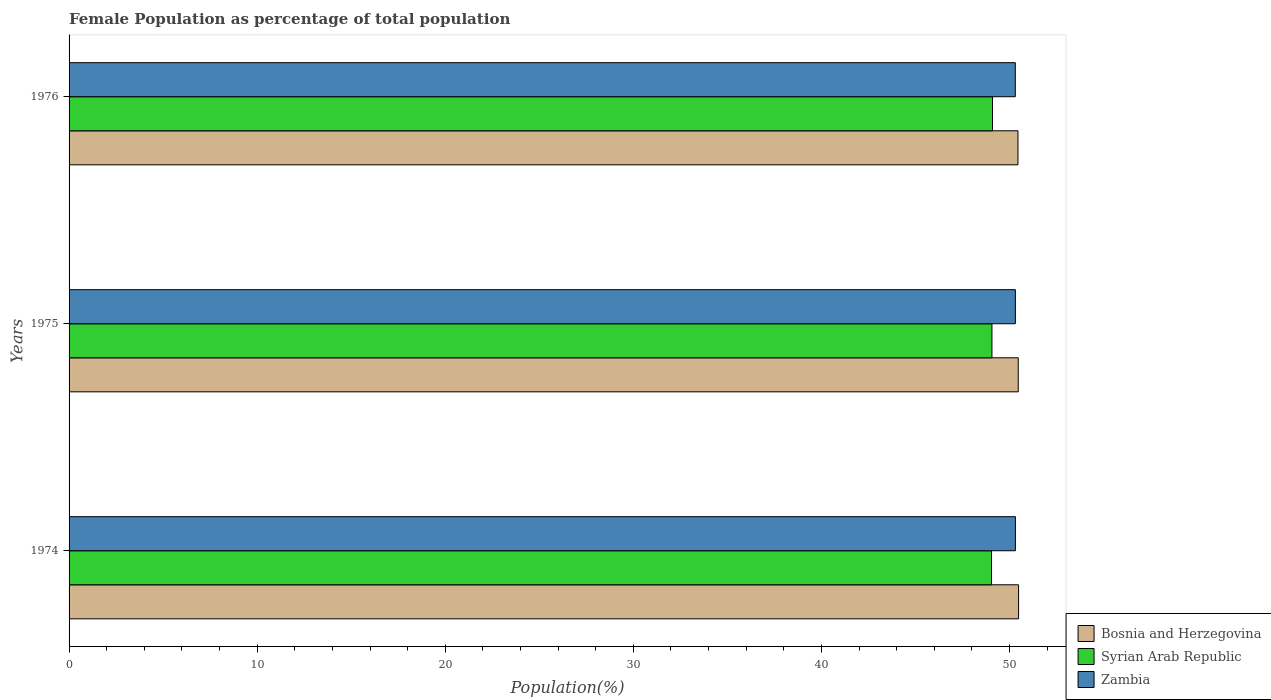How many different coloured bars are there?
Provide a short and direct response. 3. How many groups of bars are there?
Make the answer very short. 3. How many bars are there on the 1st tick from the top?
Your answer should be very brief. 3. How many bars are there on the 3rd tick from the bottom?
Offer a very short reply. 3. What is the label of the 1st group of bars from the top?
Your answer should be very brief. 1976. In how many cases, is the number of bars for a given year not equal to the number of legend labels?
Offer a terse response. 0. What is the female population in in Zambia in 1974?
Offer a very short reply. 50.31. Across all years, what is the maximum female population in in Bosnia and Herzegovina?
Provide a short and direct response. 50.48. Across all years, what is the minimum female population in in Bosnia and Herzegovina?
Your answer should be compact. 50.45. In which year was the female population in in Syrian Arab Republic maximum?
Make the answer very short. 1976. In which year was the female population in in Zambia minimum?
Provide a succinct answer. 1976. What is the total female population in in Zambia in the graph?
Provide a succinct answer. 150.94. What is the difference between the female population in in Syrian Arab Republic in 1975 and that in 1976?
Provide a short and direct response. -0.03. What is the difference between the female population in in Bosnia and Herzegovina in 1976 and the female population in in Syrian Arab Republic in 1974?
Provide a succinct answer. 1.41. What is the average female population in in Syrian Arab Republic per year?
Your answer should be compact. 49.07. In the year 1976, what is the difference between the female population in in Bosnia and Herzegovina and female population in in Zambia?
Your answer should be very brief. 0.14. In how many years, is the female population in in Bosnia and Herzegovina greater than 2 %?
Offer a very short reply. 3. What is the ratio of the female population in in Zambia in 1974 to that in 1975?
Keep it short and to the point. 1. Is the female population in in Syrian Arab Republic in 1975 less than that in 1976?
Offer a very short reply. Yes. Is the difference between the female population in in Bosnia and Herzegovina in 1975 and 1976 greater than the difference between the female population in in Zambia in 1975 and 1976?
Your answer should be very brief. Yes. What is the difference between the highest and the second highest female population in in Zambia?
Give a very brief answer. 0. What is the difference between the highest and the lowest female population in in Bosnia and Herzegovina?
Provide a short and direct response. 0.03. In how many years, is the female population in in Zambia greater than the average female population in in Zambia taken over all years?
Give a very brief answer. 2. What does the 3rd bar from the top in 1975 represents?
Your answer should be compact. Bosnia and Herzegovina. What does the 3rd bar from the bottom in 1974 represents?
Your answer should be very brief. Zambia. How many bars are there?
Ensure brevity in your answer.  9. Are all the bars in the graph horizontal?
Offer a very short reply. Yes. How many years are there in the graph?
Provide a short and direct response. 3. What is the difference between two consecutive major ticks on the X-axis?
Your answer should be very brief. 10. Does the graph contain any zero values?
Your answer should be compact. No. How are the legend labels stacked?
Your answer should be compact. Vertical. What is the title of the graph?
Your response must be concise. Female Population as percentage of total population. Does "Niger" appear as one of the legend labels in the graph?
Give a very brief answer. No. What is the label or title of the X-axis?
Provide a short and direct response. Population(%). What is the label or title of the Y-axis?
Your answer should be very brief. Years. What is the Population(%) of Bosnia and Herzegovina in 1974?
Provide a succinct answer. 50.48. What is the Population(%) in Syrian Arab Republic in 1974?
Provide a succinct answer. 49.04. What is the Population(%) in Zambia in 1974?
Your response must be concise. 50.31. What is the Population(%) of Bosnia and Herzegovina in 1975?
Provide a short and direct response. 50.47. What is the Population(%) in Syrian Arab Republic in 1975?
Your answer should be very brief. 49.07. What is the Population(%) in Zambia in 1975?
Give a very brief answer. 50.31. What is the Population(%) of Bosnia and Herzegovina in 1976?
Your answer should be compact. 50.45. What is the Population(%) in Syrian Arab Republic in 1976?
Make the answer very short. 49.1. What is the Population(%) of Zambia in 1976?
Make the answer very short. 50.31. Across all years, what is the maximum Population(%) in Bosnia and Herzegovina?
Offer a terse response. 50.48. Across all years, what is the maximum Population(%) of Syrian Arab Republic?
Keep it short and to the point. 49.1. Across all years, what is the maximum Population(%) of Zambia?
Your response must be concise. 50.31. Across all years, what is the minimum Population(%) of Bosnia and Herzegovina?
Your answer should be very brief. 50.45. Across all years, what is the minimum Population(%) in Syrian Arab Republic?
Your response must be concise. 49.04. Across all years, what is the minimum Population(%) in Zambia?
Give a very brief answer. 50.31. What is the total Population(%) in Bosnia and Herzegovina in the graph?
Your answer should be very brief. 151.4. What is the total Population(%) of Syrian Arab Republic in the graph?
Ensure brevity in your answer.  147.21. What is the total Population(%) of Zambia in the graph?
Offer a very short reply. 150.94. What is the difference between the Population(%) of Bosnia and Herzegovina in 1974 and that in 1975?
Your answer should be compact. 0.02. What is the difference between the Population(%) of Syrian Arab Republic in 1974 and that in 1975?
Keep it short and to the point. -0.02. What is the difference between the Population(%) of Zambia in 1974 and that in 1975?
Offer a terse response. 0. What is the difference between the Population(%) in Bosnia and Herzegovina in 1974 and that in 1976?
Make the answer very short. 0.03. What is the difference between the Population(%) in Syrian Arab Republic in 1974 and that in 1976?
Keep it short and to the point. -0.05. What is the difference between the Population(%) in Zambia in 1974 and that in 1976?
Your answer should be compact. 0.01. What is the difference between the Population(%) of Bosnia and Herzegovina in 1975 and that in 1976?
Offer a terse response. 0.02. What is the difference between the Population(%) of Syrian Arab Republic in 1975 and that in 1976?
Provide a short and direct response. -0.03. What is the difference between the Population(%) of Zambia in 1975 and that in 1976?
Your answer should be very brief. 0. What is the difference between the Population(%) of Bosnia and Herzegovina in 1974 and the Population(%) of Syrian Arab Republic in 1975?
Ensure brevity in your answer.  1.42. What is the difference between the Population(%) in Bosnia and Herzegovina in 1974 and the Population(%) in Zambia in 1975?
Ensure brevity in your answer.  0.17. What is the difference between the Population(%) in Syrian Arab Republic in 1974 and the Population(%) in Zambia in 1975?
Your answer should be very brief. -1.27. What is the difference between the Population(%) in Bosnia and Herzegovina in 1974 and the Population(%) in Syrian Arab Republic in 1976?
Offer a terse response. 1.39. What is the difference between the Population(%) in Bosnia and Herzegovina in 1974 and the Population(%) in Zambia in 1976?
Give a very brief answer. 0.17. What is the difference between the Population(%) in Syrian Arab Republic in 1974 and the Population(%) in Zambia in 1976?
Provide a succinct answer. -1.27. What is the difference between the Population(%) of Bosnia and Herzegovina in 1975 and the Population(%) of Syrian Arab Republic in 1976?
Keep it short and to the point. 1.37. What is the difference between the Population(%) in Bosnia and Herzegovina in 1975 and the Population(%) in Zambia in 1976?
Ensure brevity in your answer.  0.16. What is the difference between the Population(%) in Syrian Arab Republic in 1975 and the Population(%) in Zambia in 1976?
Offer a terse response. -1.24. What is the average Population(%) in Bosnia and Herzegovina per year?
Ensure brevity in your answer.  50.47. What is the average Population(%) of Syrian Arab Republic per year?
Ensure brevity in your answer.  49.07. What is the average Population(%) in Zambia per year?
Provide a succinct answer. 50.31. In the year 1974, what is the difference between the Population(%) of Bosnia and Herzegovina and Population(%) of Syrian Arab Republic?
Ensure brevity in your answer.  1.44. In the year 1974, what is the difference between the Population(%) in Bosnia and Herzegovina and Population(%) in Zambia?
Offer a very short reply. 0.17. In the year 1974, what is the difference between the Population(%) in Syrian Arab Republic and Population(%) in Zambia?
Provide a succinct answer. -1.27. In the year 1975, what is the difference between the Population(%) in Bosnia and Herzegovina and Population(%) in Syrian Arab Republic?
Your answer should be very brief. 1.4. In the year 1975, what is the difference between the Population(%) in Bosnia and Herzegovina and Population(%) in Zambia?
Your response must be concise. 0.15. In the year 1975, what is the difference between the Population(%) of Syrian Arab Republic and Population(%) of Zambia?
Your answer should be compact. -1.25. In the year 1976, what is the difference between the Population(%) of Bosnia and Herzegovina and Population(%) of Syrian Arab Republic?
Provide a succinct answer. 1.35. In the year 1976, what is the difference between the Population(%) of Bosnia and Herzegovina and Population(%) of Zambia?
Your response must be concise. 0.14. In the year 1976, what is the difference between the Population(%) of Syrian Arab Republic and Population(%) of Zambia?
Your answer should be very brief. -1.21. What is the ratio of the Population(%) of Zambia in 1974 to that in 1975?
Make the answer very short. 1. What is the ratio of the Population(%) of Syrian Arab Republic in 1974 to that in 1976?
Provide a succinct answer. 1. What is the ratio of the Population(%) in Zambia in 1975 to that in 1976?
Give a very brief answer. 1. What is the difference between the highest and the second highest Population(%) in Bosnia and Herzegovina?
Give a very brief answer. 0.02. What is the difference between the highest and the second highest Population(%) of Syrian Arab Republic?
Keep it short and to the point. 0.03. What is the difference between the highest and the second highest Population(%) of Zambia?
Offer a very short reply. 0. What is the difference between the highest and the lowest Population(%) in Bosnia and Herzegovina?
Make the answer very short. 0.03. What is the difference between the highest and the lowest Population(%) in Syrian Arab Republic?
Provide a short and direct response. 0.05. What is the difference between the highest and the lowest Population(%) of Zambia?
Ensure brevity in your answer.  0.01. 